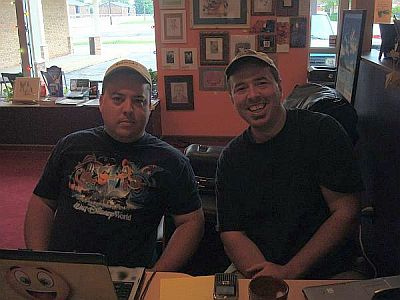<image>
Can you confirm if the laptop is on the man? No. The laptop is not positioned on the man. They may be near each other, but the laptop is not supported by or resting on top of the man. Is the man to the left of the man? Yes. From this viewpoint, the man is positioned to the left side relative to the man. 